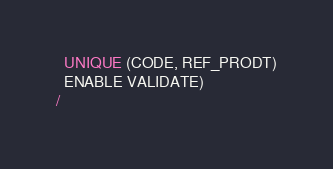<code> <loc_0><loc_0><loc_500><loc_500><_SQL_>  UNIQUE (CODE, REF_PRODT)
  ENABLE VALIDATE)
/
</code> 